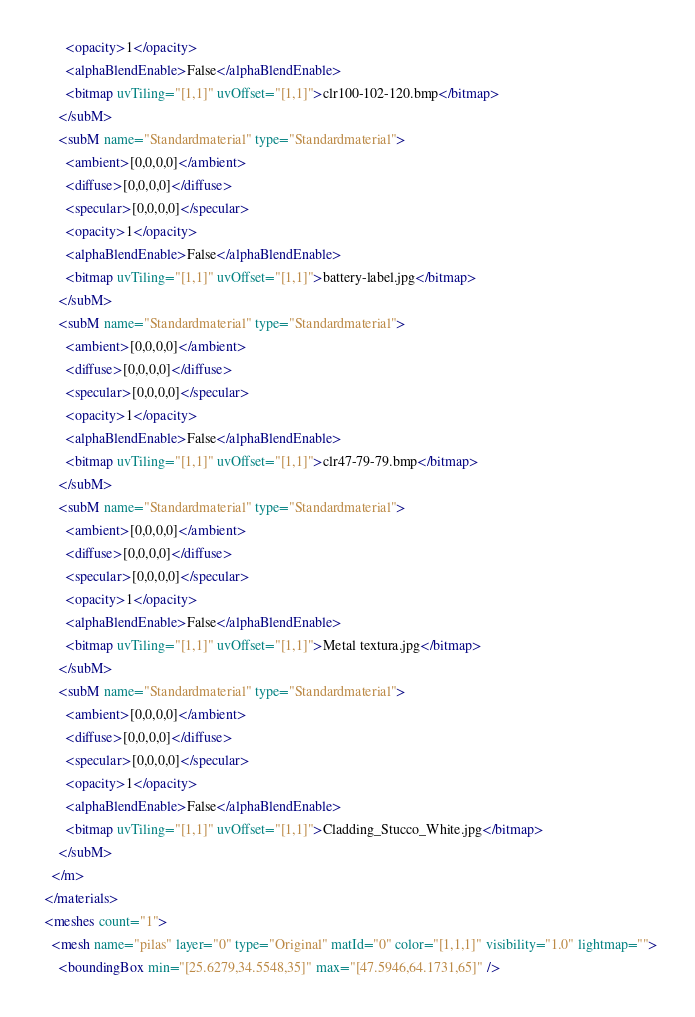<code> <loc_0><loc_0><loc_500><loc_500><_XML_>        <opacity>1</opacity>
        <alphaBlendEnable>False</alphaBlendEnable>
        <bitmap uvTiling="[1,1]" uvOffset="[1,1]">clr100-102-120.bmp</bitmap>
      </subM>
      <subM name="Standardmaterial" type="Standardmaterial">
        <ambient>[0,0,0,0]</ambient>
        <diffuse>[0,0,0,0]</diffuse>
        <specular>[0,0,0,0]</specular>
        <opacity>1</opacity>
        <alphaBlendEnable>False</alphaBlendEnable>
        <bitmap uvTiling="[1,1]" uvOffset="[1,1]">battery-label.jpg</bitmap>
      </subM>
      <subM name="Standardmaterial" type="Standardmaterial">
        <ambient>[0,0,0,0]</ambient>
        <diffuse>[0,0,0,0]</diffuse>
        <specular>[0,0,0,0]</specular>
        <opacity>1</opacity>
        <alphaBlendEnable>False</alphaBlendEnable>
        <bitmap uvTiling="[1,1]" uvOffset="[1,1]">clr47-79-79.bmp</bitmap>
      </subM>
      <subM name="Standardmaterial" type="Standardmaterial">
        <ambient>[0,0,0,0]</ambient>
        <diffuse>[0,0,0,0]</diffuse>
        <specular>[0,0,0,0]</specular>
        <opacity>1</opacity>
        <alphaBlendEnable>False</alphaBlendEnable>
        <bitmap uvTiling="[1,1]" uvOffset="[1,1]">Metal textura.jpg</bitmap>
      </subM>
      <subM name="Standardmaterial" type="Standardmaterial">
        <ambient>[0,0,0,0]</ambient>
        <diffuse>[0,0,0,0]</diffuse>
        <specular>[0,0,0,0]</specular>
        <opacity>1</opacity>
        <alphaBlendEnable>False</alphaBlendEnable>
        <bitmap uvTiling="[1,1]" uvOffset="[1,1]">Cladding_Stucco_White.jpg</bitmap>
      </subM>
    </m>
  </materials>
  <meshes count="1">
    <mesh name="pilas" layer="0" type="Original" matId="0" color="[1,1,1]" visibility="1.0" lightmap="">
      <boundingBox min="[25.6279,34.5548,35]" max="[47.5946,64.1731,65]" /></code> 